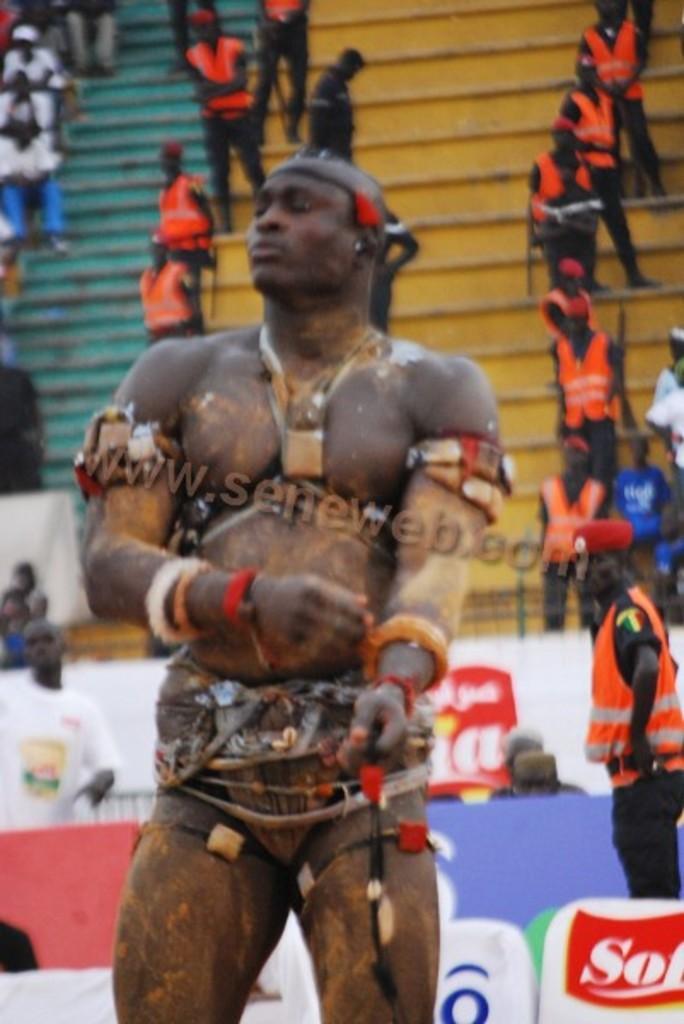Could you give a brief overview of what you see in this image? In this image there is a person standing, behind the person there are a few sponsor boards, behind that there are a few people standing in the stands. 